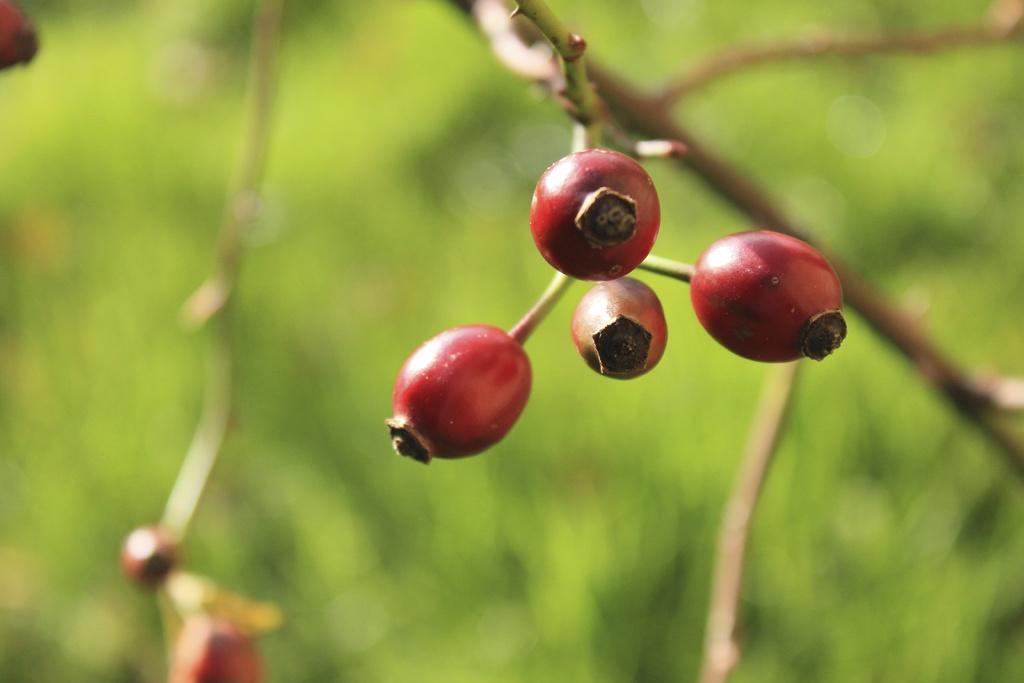How would you summarize this image in a sentence or two? In this picture I can see there are red color fruits attached to the stem and the backdrop is blurred. 